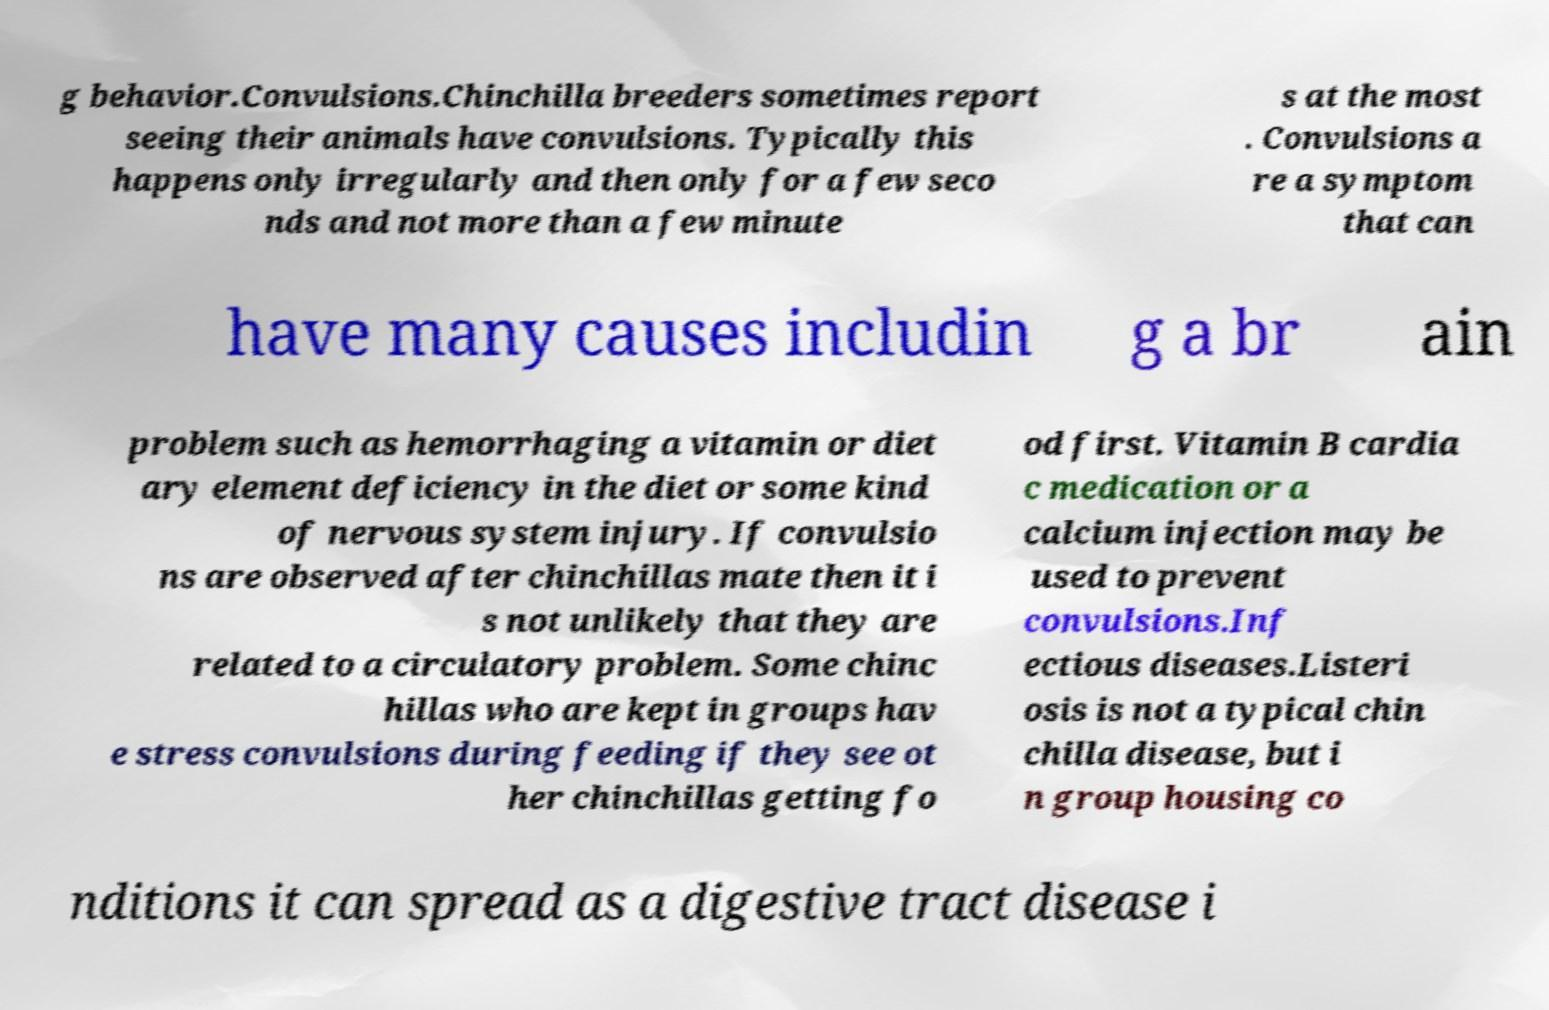There's text embedded in this image that I need extracted. Can you transcribe it verbatim? g behavior.Convulsions.Chinchilla breeders sometimes report seeing their animals have convulsions. Typically this happens only irregularly and then only for a few seco nds and not more than a few minute s at the most . Convulsions a re a symptom that can have many causes includin g a br ain problem such as hemorrhaging a vitamin or diet ary element deficiency in the diet or some kind of nervous system injury. If convulsio ns are observed after chinchillas mate then it i s not unlikely that they are related to a circulatory problem. Some chinc hillas who are kept in groups hav e stress convulsions during feeding if they see ot her chinchillas getting fo od first. Vitamin B cardia c medication or a calcium injection may be used to prevent convulsions.Inf ectious diseases.Listeri osis is not a typical chin chilla disease, but i n group housing co nditions it can spread as a digestive tract disease i 